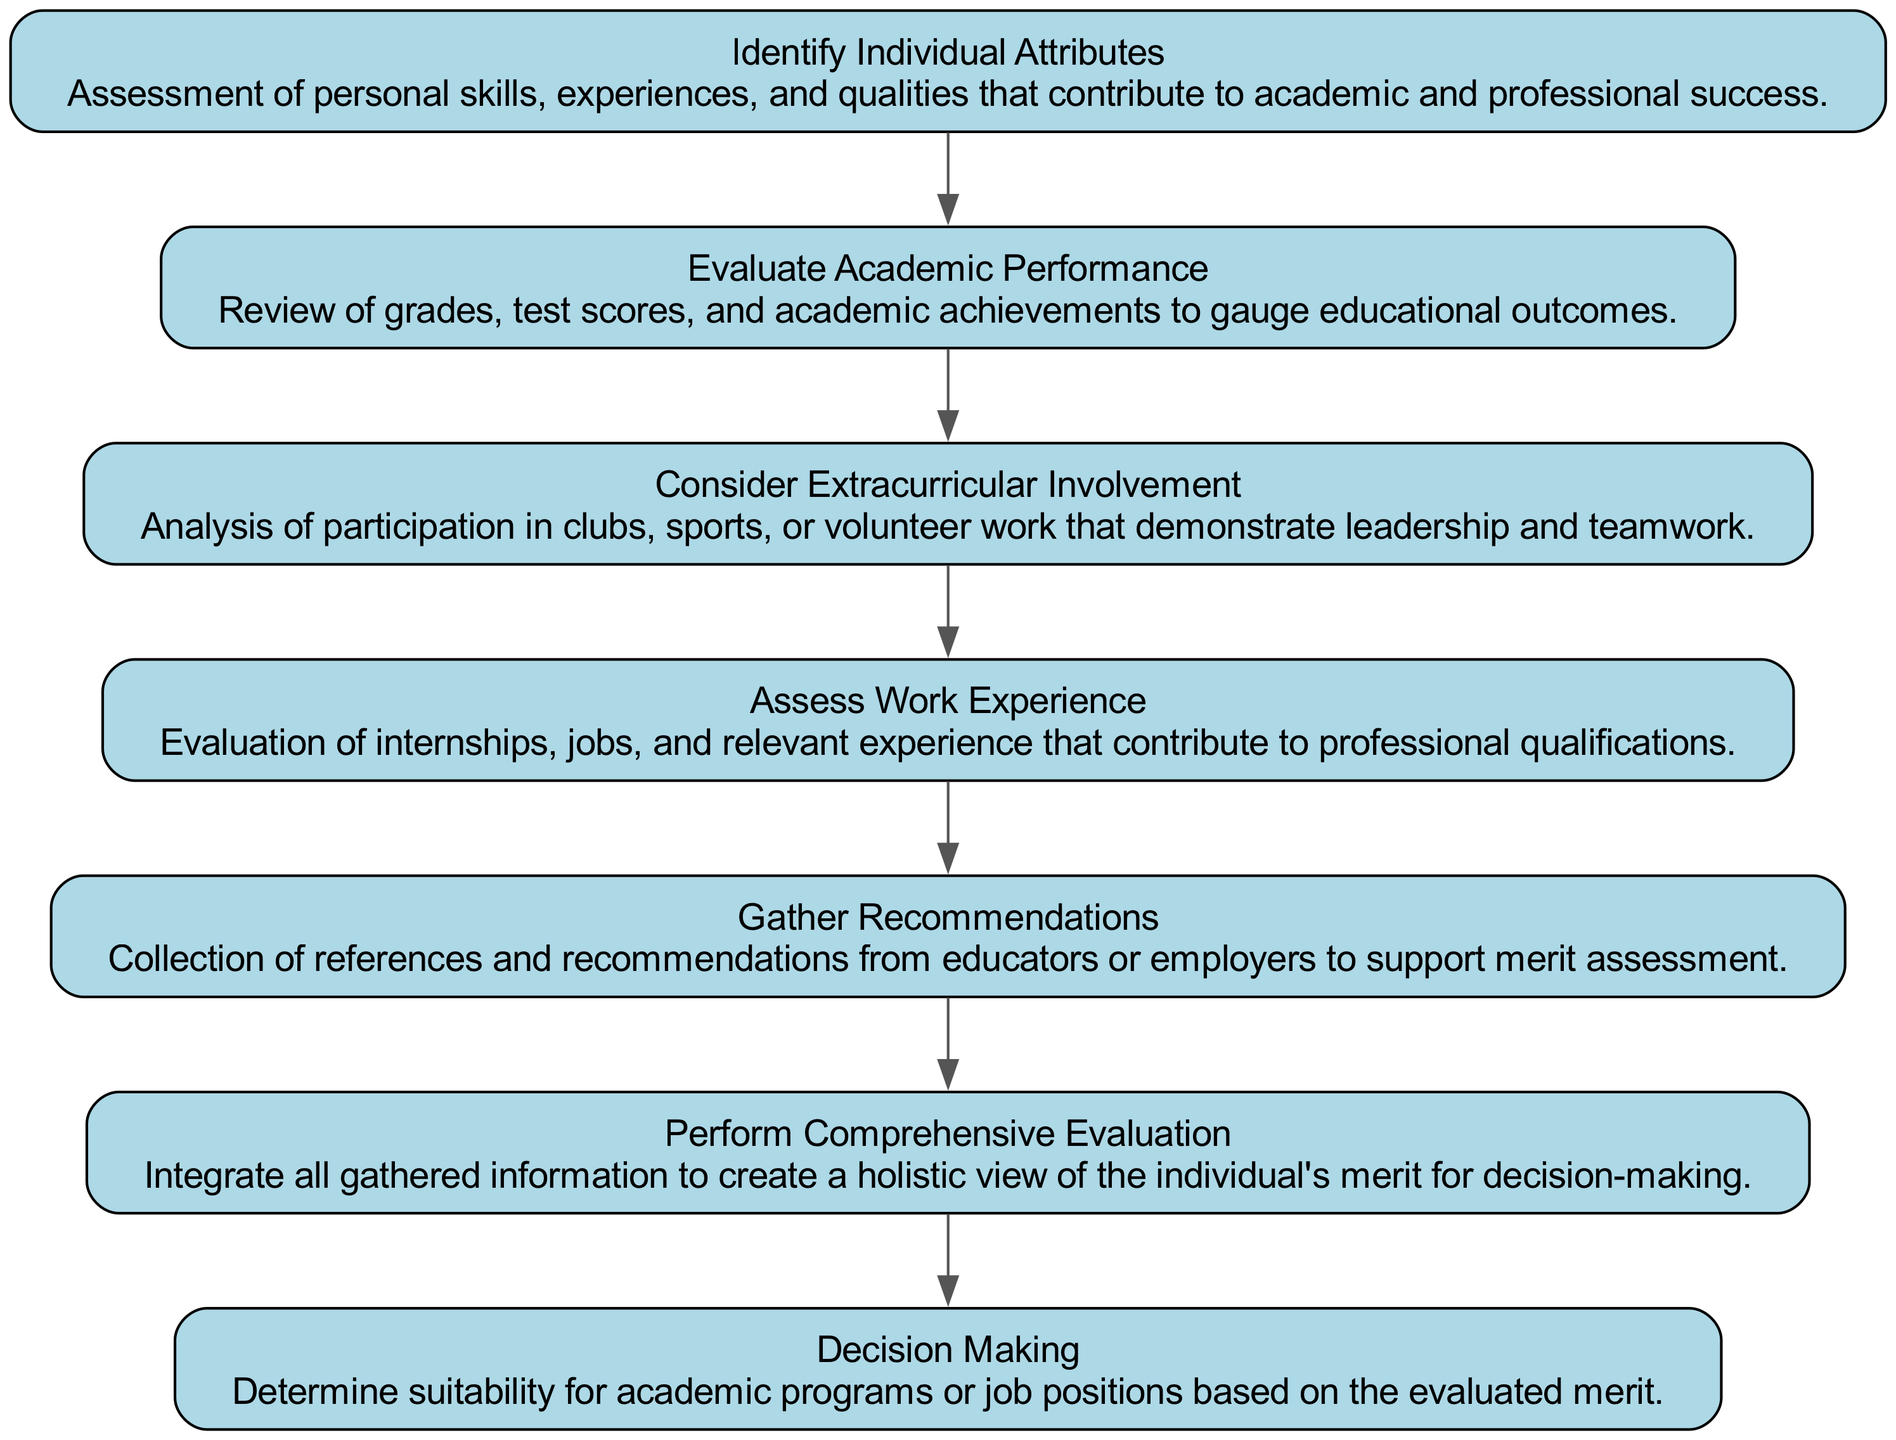What is the first step in the decision-making process? The first step is identified as "Identify Individual Attributes," indicating that personal skills, experiences, and qualities are assessed.
Answer: Identify Individual Attributes How many nodes are present in the diagram? The diagram has a total of 7 nodes, representing different steps in the decision-making process.
Answer: 7 What aspect does the second node focus on? The second node, "Evaluate Academic Performance," focuses on reviewing grades, test scores, and academic achievements to gauge educational outcomes.
Answer: Evaluate Academic Performance What are the two last steps in the process? The last two steps are "Gather Recommendations" and "Perform Comprehensive Evaluation," which imply collecting references and creating a holistic view of merit.
Answer: Gather Recommendations and Perform Comprehensive Evaluation Which node follows "Assess Work Experience"? The node that follows "Assess Work Experience" is "Gather Recommendations," which involves collecting references and recommendations.
Answer: Gather Recommendations What is the final decision made in the process? The final decision made in the process is represented by the node "Decision Making," where suitability for academic programs or job positions is determined based on evaluated merit.
Answer: Decision Making How does "Consider Extracurricular Involvement" relate to the overall evaluation? "Consider Extracurricular Involvement" contributes to the overall evaluation by analyzing participation in clubs, sports, or volunteer work that demonstrate leadership and teamwork, thus enhancing the assessment of individual merit.
Answer: Analyzing participation in clubs, sports, or volunteer work What is the role of the "Perform Comprehensive Evaluation" step? The role of "Perform Comprehensive Evaluation" is to integrate all gathered information to create a holistic view of the individual's merit for decision-making.
Answer: Integrate all gathered information 